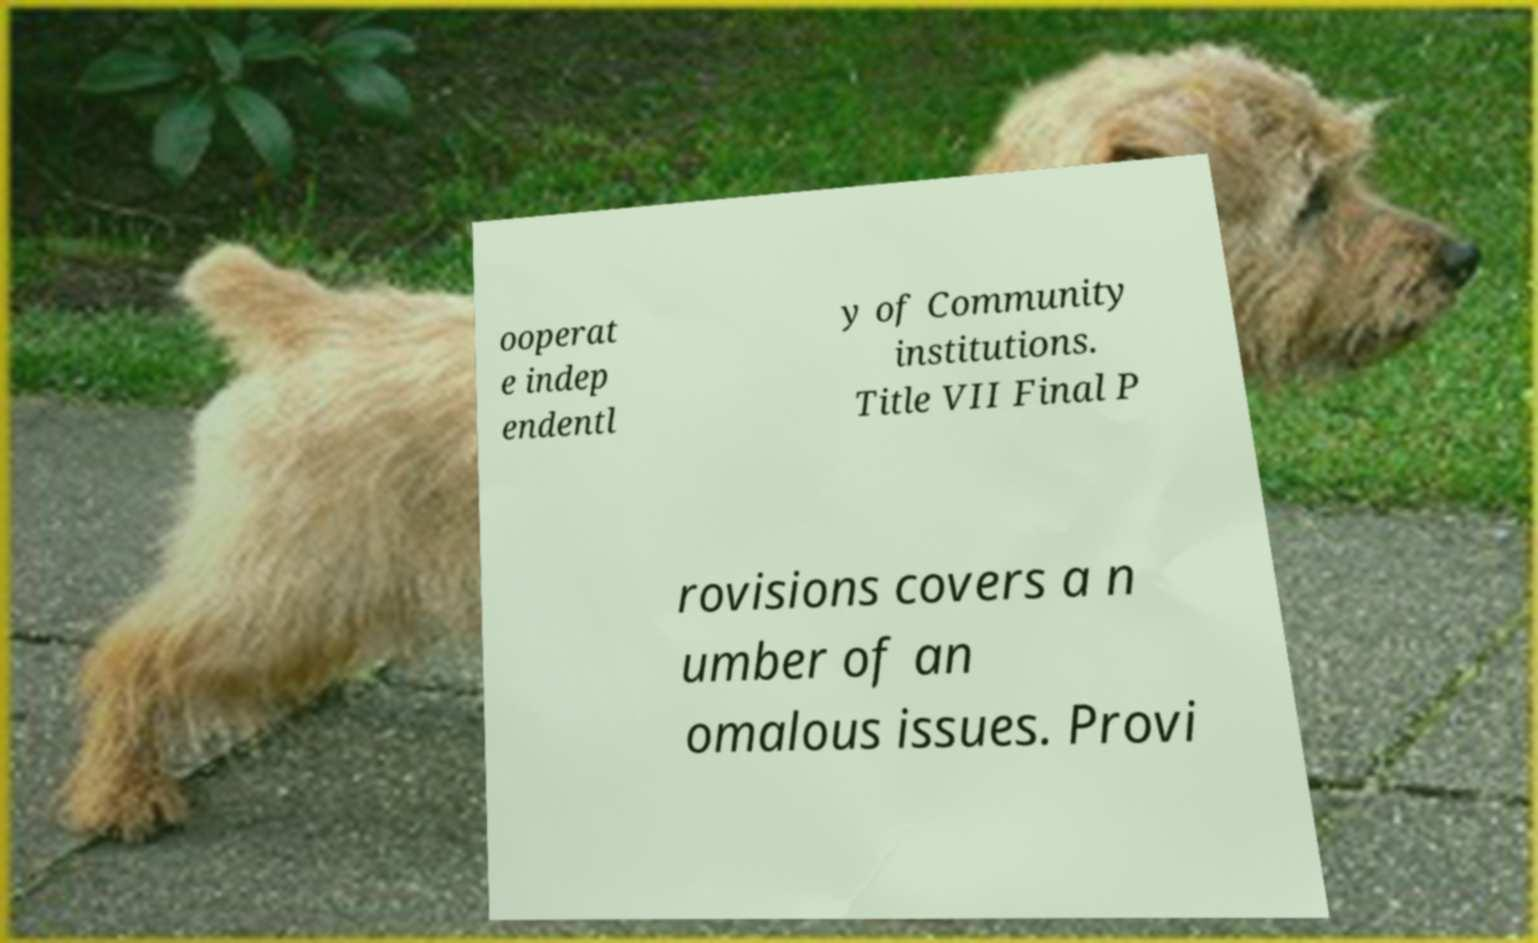Please identify and transcribe the text found in this image. ooperat e indep endentl y of Community institutions. Title VII Final P rovisions covers a n umber of an omalous issues. Provi 